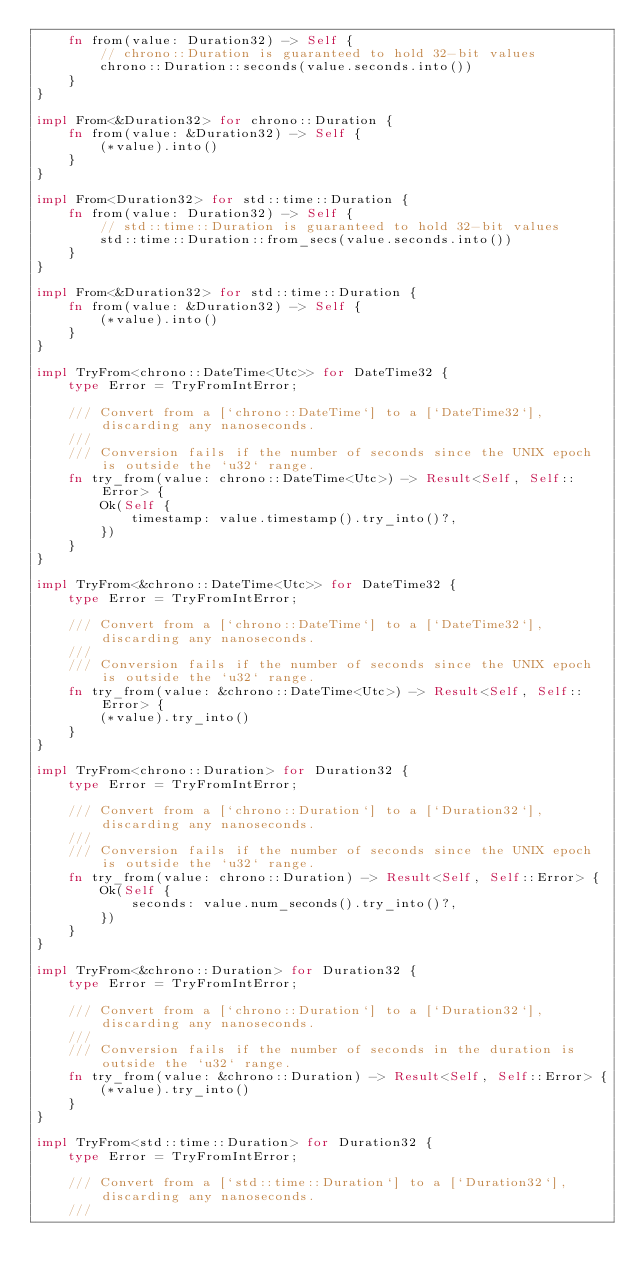Convert code to text. <code><loc_0><loc_0><loc_500><loc_500><_Rust_>    fn from(value: Duration32) -> Self {
        // chrono::Duration is guaranteed to hold 32-bit values
        chrono::Duration::seconds(value.seconds.into())
    }
}

impl From<&Duration32> for chrono::Duration {
    fn from(value: &Duration32) -> Self {
        (*value).into()
    }
}

impl From<Duration32> for std::time::Duration {
    fn from(value: Duration32) -> Self {
        // std::time::Duration is guaranteed to hold 32-bit values
        std::time::Duration::from_secs(value.seconds.into())
    }
}

impl From<&Duration32> for std::time::Duration {
    fn from(value: &Duration32) -> Self {
        (*value).into()
    }
}

impl TryFrom<chrono::DateTime<Utc>> for DateTime32 {
    type Error = TryFromIntError;

    /// Convert from a [`chrono::DateTime`] to a [`DateTime32`], discarding any nanoseconds.
    ///
    /// Conversion fails if the number of seconds since the UNIX epoch is outside the `u32` range.
    fn try_from(value: chrono::DateTime<Utc>) -> Result<Self, Self::Error> {
        Ok(Self {
            timestamp: value.timestamp().try_into()?,
        })
    }
}

impl TryFrom<&chrono::DateTime<Utc>> for DateTime32 {
    type Error = TryFromIntError;

    /// Convert from a [`chrono::DateTime`] to a [`DateTime32`], discarding any nanoseconds.
    ///
    /// Conversion fails if the number of seconds since the UNIX epoch is outside the `u32` range.
    fn try_from(value: &chrono::DateTime<Utc>) -> Result<Self, Self::Error> {
        (*value).try_into()
    }
}

impl TryFrom<chrono::Duration> for Duration32 {
    type Error = TryFromIntError;

    /// Convert from a [`chrono::Duration`] to a [`Duration32`], discarding any nanoseconds.
    ///
    /// Conversion fails if the number of seconds since the UNIX epoch is outside the `u32` range.
    fn try_from(value: chrono::Duration) -> Result<Self, Self::Error> {
        Ok(Self {
            seconds: value.num_seconds().try_into()?,
        })
    }
}

impl TryFrom<&chrono::Duration> for Duration32 {
    type Error = TryFromIntError;

    /// Convert from a [`chrono::Duration`] to a [`Duration32`], discarding any nanoseconds.
    ///
    /// Conversion fails if the number of seconds in the duration is outside the `u32` range.
    fn try_from(value: &chrono::Duration) -> Result<Self, Self::Error> {
        (*value).try_into()
    }
}

impl TryFrom<std::time::Duration> for Duration32 {
    type Error = TryFromIntError;

    /// Convert from a [`std::time::Duration`] to a [`Duration32`], discarding any nanoseconds.
    ///</code> 